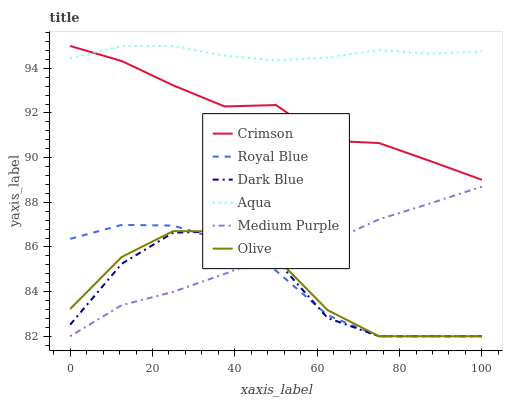Does Dark Blue have the minimum area under the curve?
Answer yes or no. Yes. Does Aqua have the maximum area under the curve?
Answer yes or no. Yes. Does Medium Purple have the minimum area under the curve?
Answer yes or no. No. Does Medium Purple have the maximum area under the curve?
Answer yes or no. No. Is Medium Purple the smoothest?
Answer yes or no. Yes. Is Dark Blue the roughest?
Answer yes or no. Yes. Is Aqua the smoothest?
Answer yes or no. No. Is Aqua the roughest?
Answer yes or no. No. Does Olive have the lowest value?
Answer yes or no. Yes. Does Aqua have the lowest value?
Answer yes or no. No. Does Crimson have the highest value?
Answer yes or no. Yes. Does Medium Purple have the highest value?
Answer yes or no. No. Is Olive less than Crimson?
Answer yes or no. Yes. Is Crimson greater than Olive?
Answer yes or no. Yes. Does Olive intersect Dark Blue?
Answer yes or no. Yes. Is Olive less than Dark Blue?
Answer yes or no. No. Is Olive greater than Dark Blue?
Answer yes or no. No. Does Olive intersect Crimson?
Answer yes or no. No. 